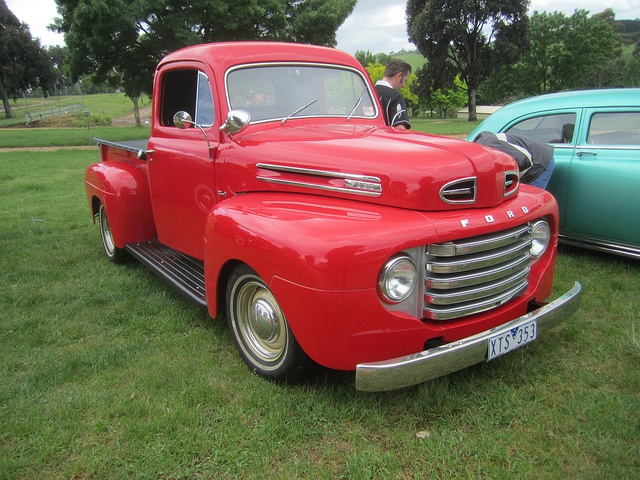Describe the objects in this image and their specific colors. I can see truck in gray, brown, salmon, black, and darkgray tones, car in gray, brown, salmon, black, and darkgray tones, car in gray, turquoise, teal, and darkgray tones, people in gray and black tones, and people in gray and black tones in this image. 